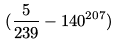Convert formula to latex. <formula><loc_0><loc_0><loc_500><loc_500>( \frac { 5 } { 2 3 9 } - 1 4 0 ^ { 2 0 7 } )</formula> 